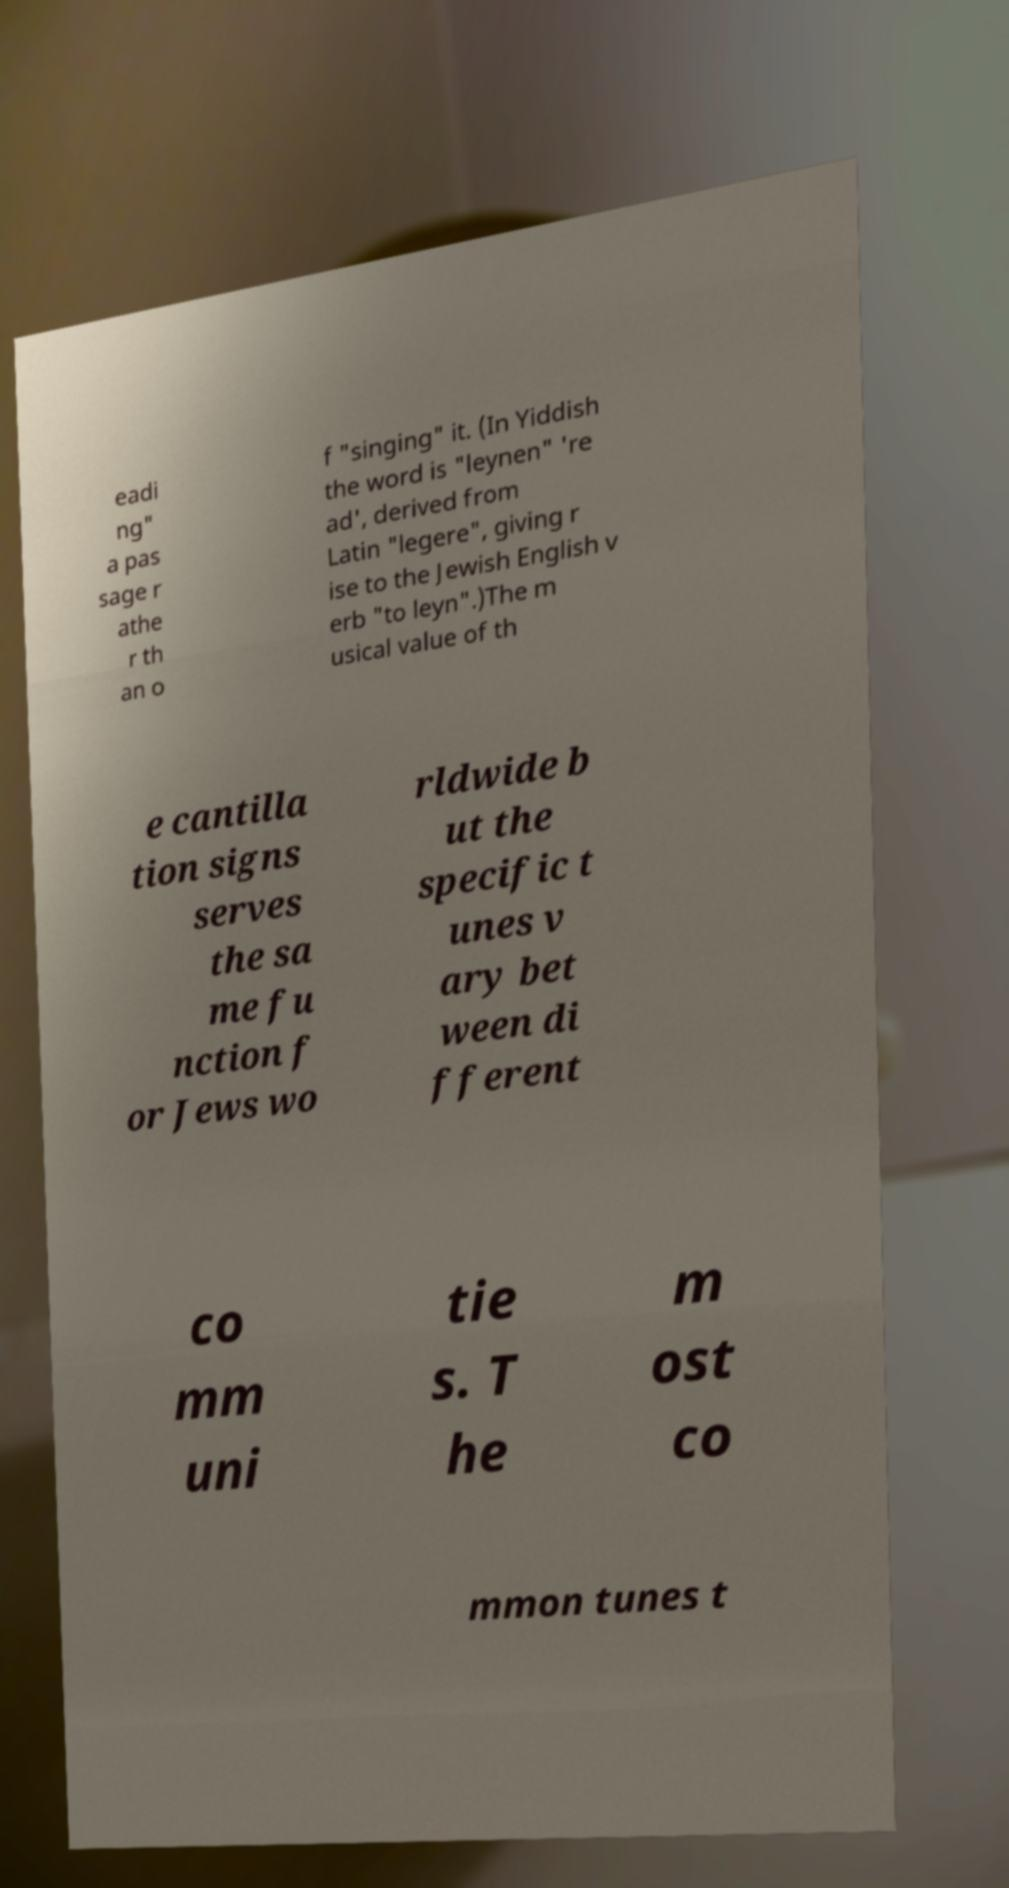Could you assist in decoding the text presented in this image and type it out clearly? eadi ng" a pas sage r athe r th an o f "singing" it. (In Yiddish the word is "leynen" 're ad', derived from Latin "legere", giving r ise to the Jewish English v erb "to leyn".)The m usical value of th e cantilla tion signs serves the sa me fu nction f or Jews wo rldwide b ut the specific t unes v ary bet ween di fferent co mm uni tie s. T he m ost co mmon tunes t 